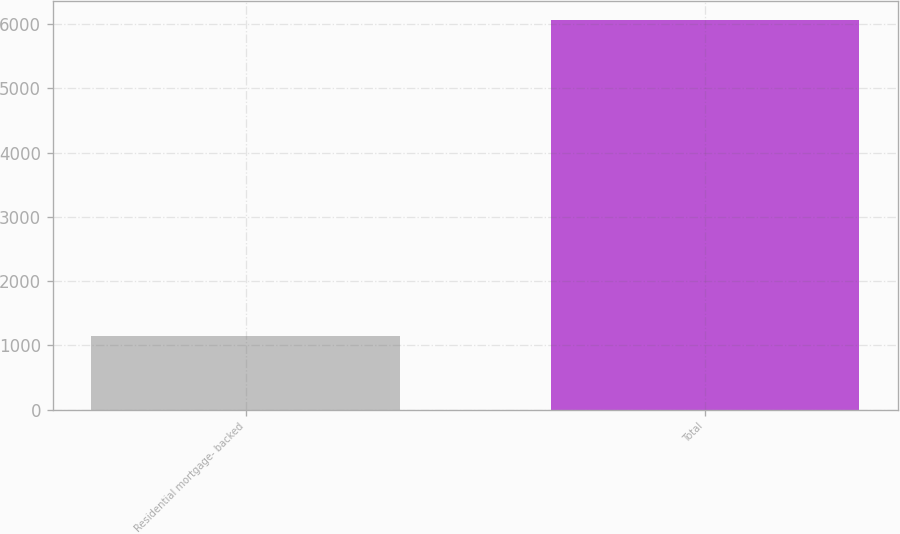<chart> <loc_0><loc_0><loc_500><loc_500><bar_chart><fcel>Residential mortgage- backed<fcel>Total<nl><fcel>1139<fcel>6062<nl></chart> 